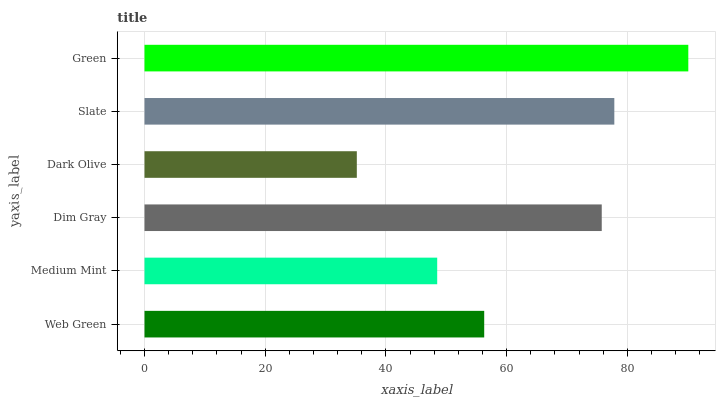Is Dark Olive the minimum?
Answer yes or no. Yes. Is Green the maximum?
Answer yes or no. Yes. Is Medium Mint the minimum?
Answer yes or no. No. Is Medium Mint the maximum?
Answer yes or no. No. Is Web Green greater than Medium Mint?
Answer yes or no. Yes. Is Medium Mint less than Web Green?
Answer yes or no. Yes. Is Medium Mint greater than Web Green?
Answer yes or no. No. Is Web Green less than Medium Mint?
Answer yes or no. No. Is Dim Gray the high median?
Answer yes or no. Yes. Is Web Green the low median?
Answer yes or no. Yes. Is Green the high median?
Answer yes or no. No. Is Slate the low median?
Answer yes or no. No. 